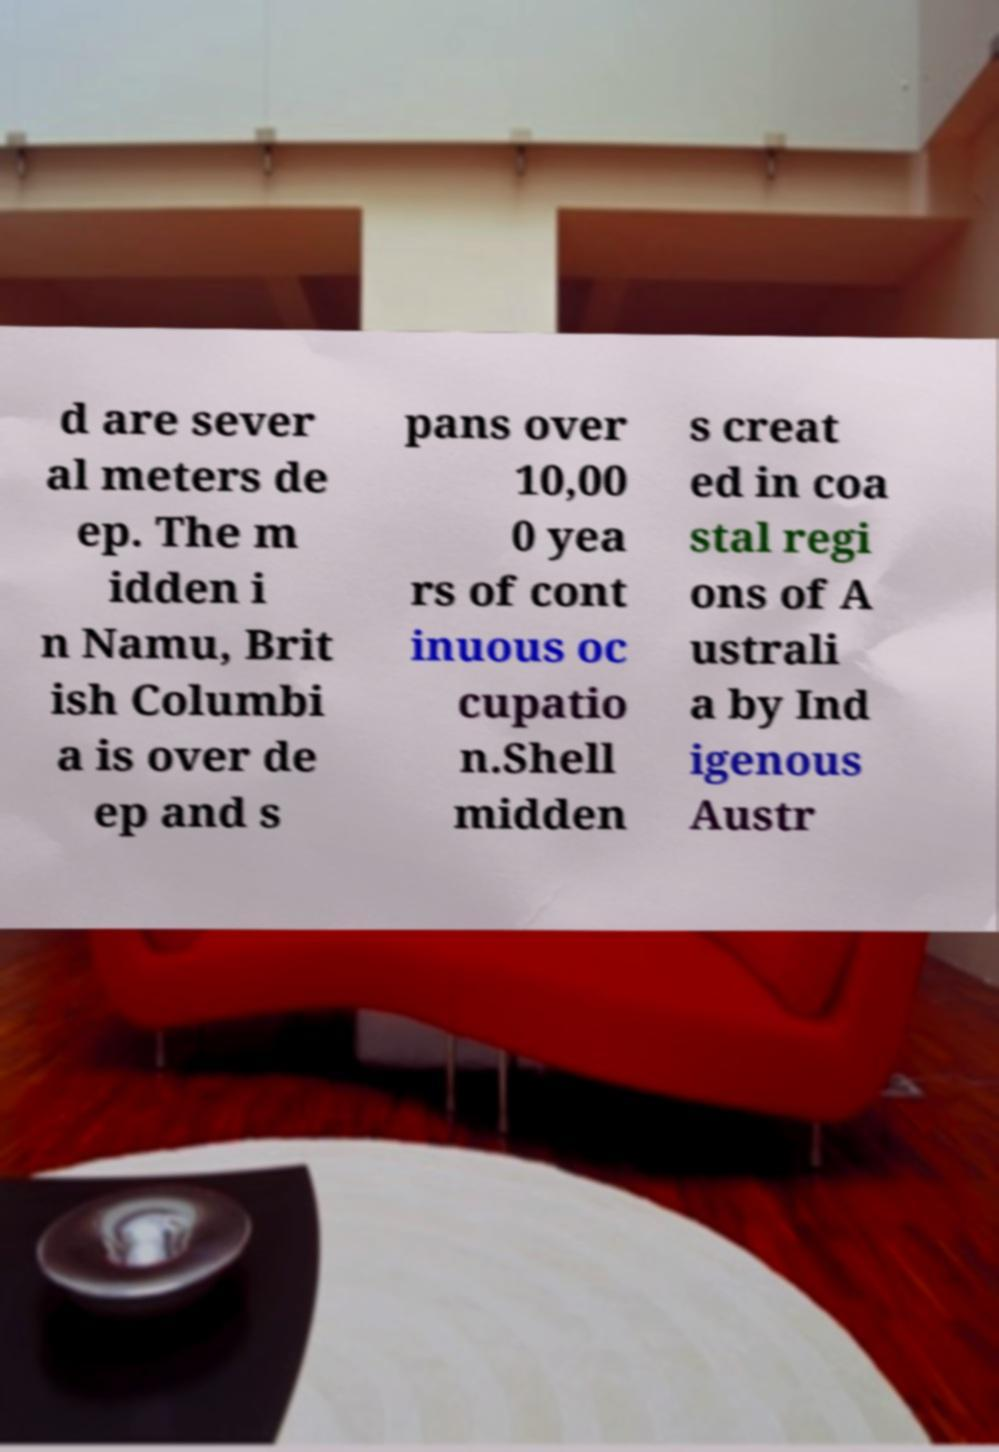For documentation purposes, I need the text within this image transcribed. Could you provide that? d are sever al meters de ep. The m idden i n Namu, Brit ish Columbi a is over de ep and s pans over 10,00 0 yea rs of cont inuous oc cupatio n.Shell midden s creat ed in coa stal regi ons of A ustrali a by Ind igenous Austr 